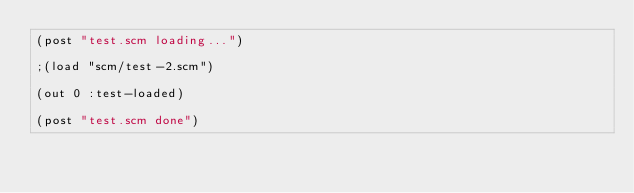Convert code to text. <code><loc_0><loc_0><loc_500><loc_500><_Scheme_>(post "test.scm loading...")

;(load "scm/test-2.scm")

(out 0 :test-loaded)

(post "test.scm done")
</code> 